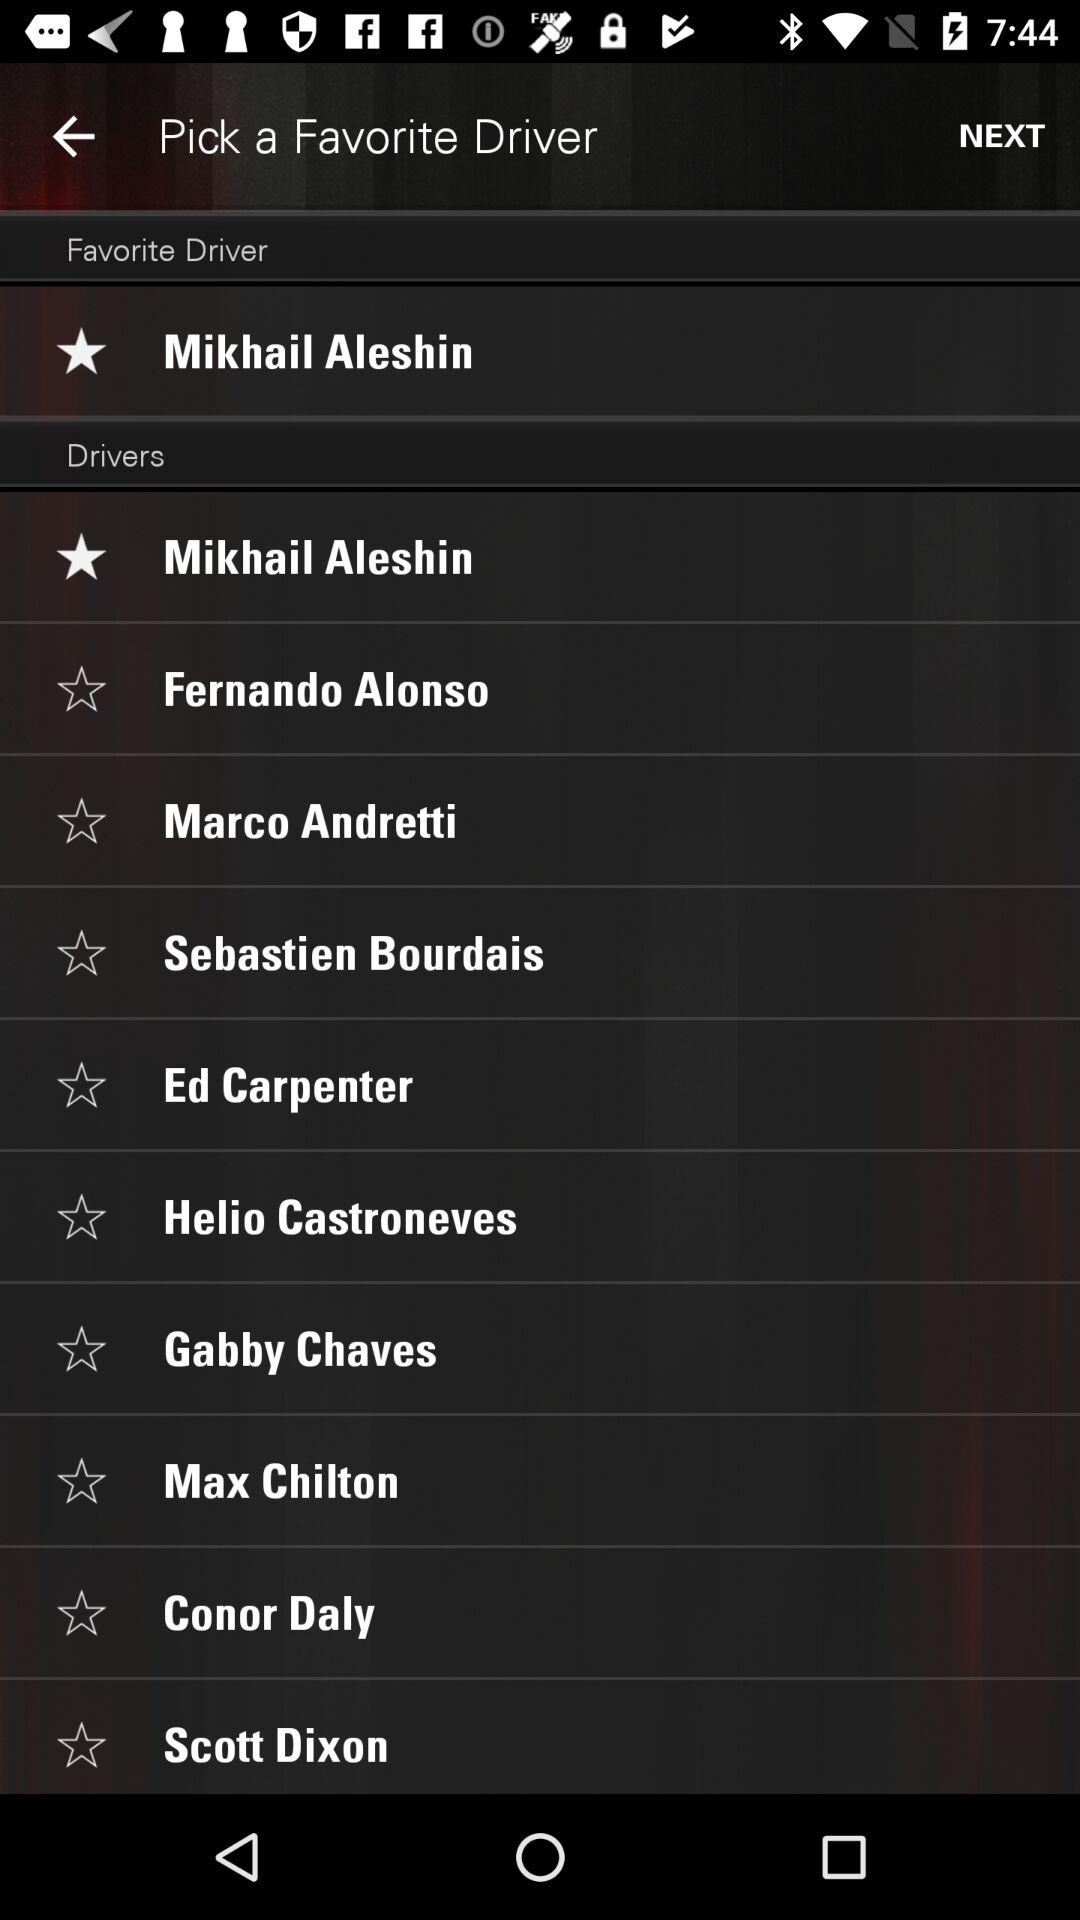Who is selected as the favorite driver? The favorite driver is "Mikhail Aleshin". 